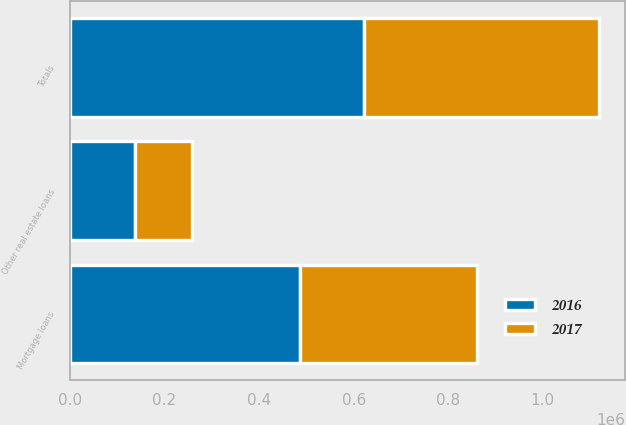Convert chart. <chart><loc_0><loc_0><loc_500><loc_500><stacked_bar_chart><ecel><fcel>Mortgage loans<fcel>Other real estate loans<fcel>Totals<nl><fcel>2017<fcel>374492<fcel>121379<fcel>495871<nl><fcel>2016<fcel>485735<fcel>136893<fcel>622628<nl></chart> 